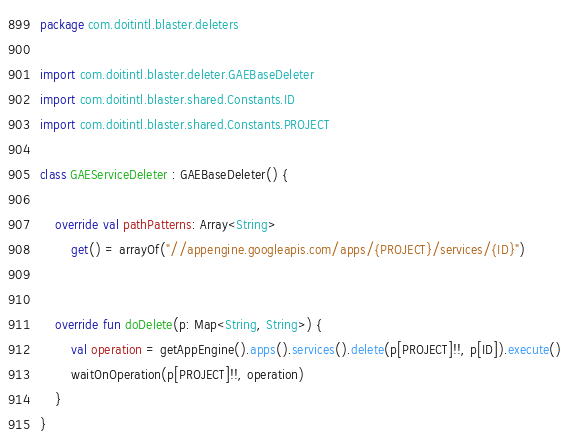Convert code to text. <code><loc_0><loc_0><loc_500><loc_500><_Kotlin_>package com.doitintl.blaster.deleters

import com.doitintl.blaster.deleter.GAEBaseDeleter
import com.doitintl.blaster.shared.Constants.ID
import com.doitintl.blaster.shared.Constants.PROJECT

class GAEServiceDeleter : GAEBaseDeleter() {

    override val pathPatterns: Array<String>
        get() = arrayOf("//appengine.googleapis.com/apps/{PROJECT}/services/{ID}")


    override fun doDelete(p: Map<String, String>) {
        val operation = getAppEngine().apps().services().delete(p[PROJECT]!!, p[ID]).execute()
        waitOnOperation(p[PROJECT]!!, operation)
    }
}</code> 